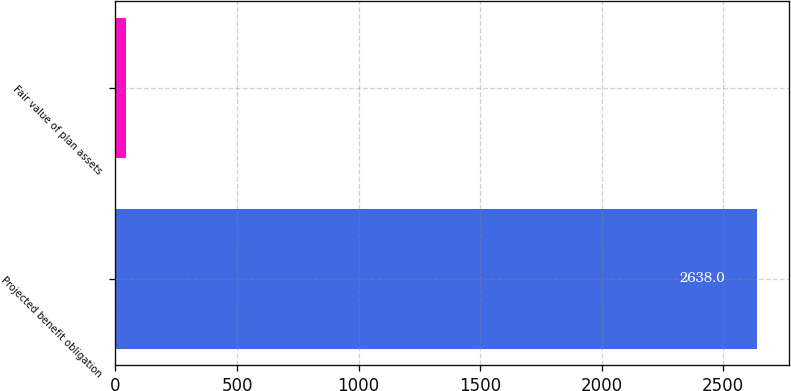Convert chart to OTSL. <chart><loc_0><loc_0><loc_500><loc_500><bar_chart><fcel>Projected benefit obligation<fcel>Fair value of plan assets<nl><fcel>2638<fcel>44<nl></chart> 